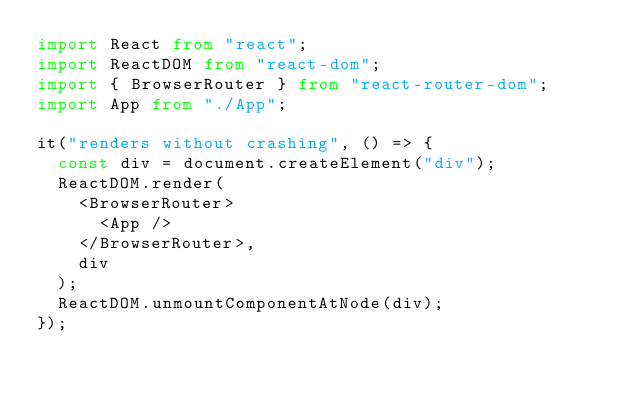<code> <loc_0><loc_0><loc_500><loc_500><_TypeScript_>import React from "react";
import ReactDOM from "react-dom";
import { BrowserRouter } from "react-router-dom";
import App from "./App";

it("renders without crashing", () => {
  const div = document.createElement("div");
  ReactDOM.render(
    <BrowserRouter>
      <App />
    </BrowserRouter>,
    div
  );
  ReactDOM.unmountComponentAtNode(div);
});
</code> 